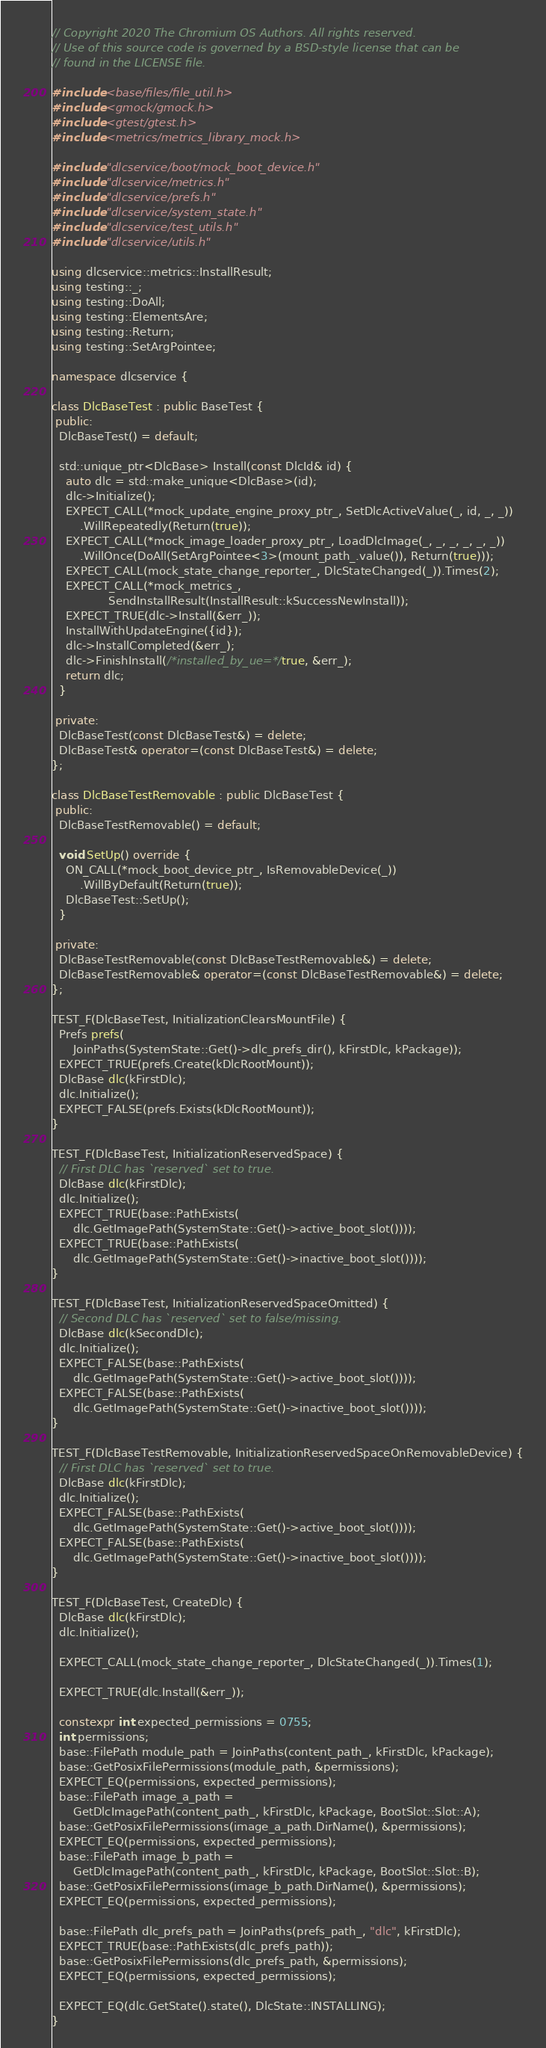<code> <loc_0><loc_0><loc_500><loc_500><_C++_>// Copyright 2020 The Chromium OS Authors. All rights reserved.
// Use of this source code is governed by a BSD-style license that can be
// found in the LICENSE file.

#include <base/files/file_util.h>
#include <gmock/gmock.h>
#include <gtest/gtest.h>
#include <metrics/metrics_library_mock.h>

#include "dlcservice/boot/mock_boot_device.h"
#include "dlcservice/metrics.h"
#include "dlcservice/prefs.h"
#include "dlcservice/system_state.h"
#include "dlcservice/test_utils.h"
#include "dlcservice/utils.h"

using dlcservice::metrics::InstallResult;
using testing::_;
using testing::DoAll;
using testing::ElementsAre;
using testing::Return;
using testing::SetArgPointee;

namespace dlcservice {

class DlcBaseTest : public BaseTest {
 public:
  DlcBaseTest() = default;

  std::unique_ptr<DlcBase> Install(const DlcId& id) {
    auto dlc = std::make_unique<DlcBase>(id);
    dlc->Initialize();
    EXPECT_CALL(*mock_update_engine_proxy_ptr_, SetDlcActiveValue(_, id, _, _))
        .WillRepeatedly(Return(true));
    EXPECT_CALL(*mock_image_loader_proxy_ptr_, LoadDlcImage(_, _, _, _, _, _))
        .WillOnce(DoAll(SetArgPointee<3>(mount_path_.value()), Return(true)));
    EXPECT_CALL(mock_state_change_reporter_, DlcStateChanged(_)).Times(2);
    EXPECT_CALL(*mock_metrics_,
                SendInstallResult(InstallResult::kSuccessNewInstall));
    EXPECT_TRUE(dlc->Install(&err_));
    InstallWithUpdateEngine({id});
    dlc->InstallCompleted(&err_);
    dlc->FinishInstall(/*installed_by_ue=*/true, &err_);
    return dlc;
  }

 private:
  DlcBaseTest(const DlcBaseTest&) = delete;
  DlcBaseTest& operator=(const DlcBaseTest&) = delete;
};

class DlcBaseTestRemovable : public DlcBaseTest {
 public:
  DlcBaseTestRemovable() = default;

  void SetUp() override {
    ON_CALL(*mock_boot_device_ptr_, IsRemovableDevice(_))
        .WillByDefault(Return(true));
    DlcBaseTest::SetUp();
  }

 private:
  DlcBaseTestRemovable(const DlcBaseTestRemovable&) = delete;
  DlcBaseTestRemovable& operator=(const DlcBaseTestRemovable&) = delete;
};

TEST_F(DlcBaseTest, InitializationClearsMountFile) {
  Prefs prefs(
      JoinPaths(SystemState::Get()->dlc_prefs_dir(), kFirstDlc, kPackage));
  EXPECT_TRUE(prefs.Create(kDlcRootMount));
  DlcBase dlc(kFirstDlc);
  dlc.Initialize();
  EXPECT_FALSE(prefs.Exists(kDlcRootMount));
}

TEST_F(DlcBaseTest, InitializationReservedSpace) {
  // First DLC has `reserved` set to true.
  DlcBase dlc(kFirstDlc);
  dlc.Initialize();
  EXPECT_TRUE(base::PathExists(
      dlc.GetImagePath(SystemState::Get()->active_boot_slot())));
  EXPECT_TRUE(base::PathExists(
      dlc.GetImagePath(SystemState::Get()->inactive_boot_slot())));
}

TEST_F(DlcBaseTest, InitializationReservedSpaceOmitted) {
  // Second DLC has `reserved` set to false/missing.
  DlcBase dlc(kSecondDlc);
  dlc.Initialize();
  EXPECT_FALSE(base::PathExists(
      dlc.GetImagePath(SystemState::Get()->active_boot_slot())));
  EXPECT_FALSE(base::PathExists(
      dlc.GetImagePath(SystemState::Get()->inactive_boot_slot())));
}

TEST_F(DlcBaseTestRemovable, InitializationReservedSpaceOnRemovableDevice) {
  // First DLC has `reserved` set to true.
  DlcBase dlc(kFirstDlc);
  dlc.Initialize();
  EXPECT_FALSE(base::PathExists(
      dlc.GetImagePath(SystemState::Get()->active_boot_slot())));
  EXPECT_FALSE(base::PathExists(
      dlc.GetImagePath(SystemState::Get()->inactive_boot_slot())));
}

TEST_F(DlcBaseTest, CreateDlc) {
  DlcBase dlc(kFirstDlc);
  dlc.Initialize();

  EXPECT_CALL(mock_state_change_reporter_, DlcStateChanged(_)).Times(1);

  EXPECT_TRUE(dlc.Install(&err_));

  constexpr int expected_permissions = 0755;
  int permissions;
  base::FilePath module_path = JoinPaths(content_path_, kFirstDlc, kPackage);
  base::GetPosixFilePermissions(module_path, &permissions);
  EXPECT_EQ(permissions, expected_permissions);
  base::FilePath image_a_path =
      GetDlcImagePath(content_path_, kFirstDlc, kPackage, BootSlot::Slot::A);
  base::GetPosixFilePermissions(image_a_path.DirName(), &permissions);
  EXPECT_EQ(permissions, expected_permissions);
  base::FilePath image_b_path =
      GetDlcImagePath(content_path_, kFirstDlc, kPackage, BootSlot::Slot::B);
  base::GetPosixFilePermissions(image_b_path.DirName(), &permissions);
  EXPECT_EQ(permissions, expected_permissions);

  base::FilePath dlc_prefs_path = JoinPaths(prefs_path_, "dlc", kFirstDlc);
  EXPECT_TRUE(base::PathExists(dlc_prefs_path));
  base::GetPosixFilePermissions(dlc_prefs_path, &permissions);
  EXPECT_EQ(permissions, expected_permissions);

  EXPECT_EQ(dlc.GetState().state(), DlcState::INSTALLING);
}
</code> 